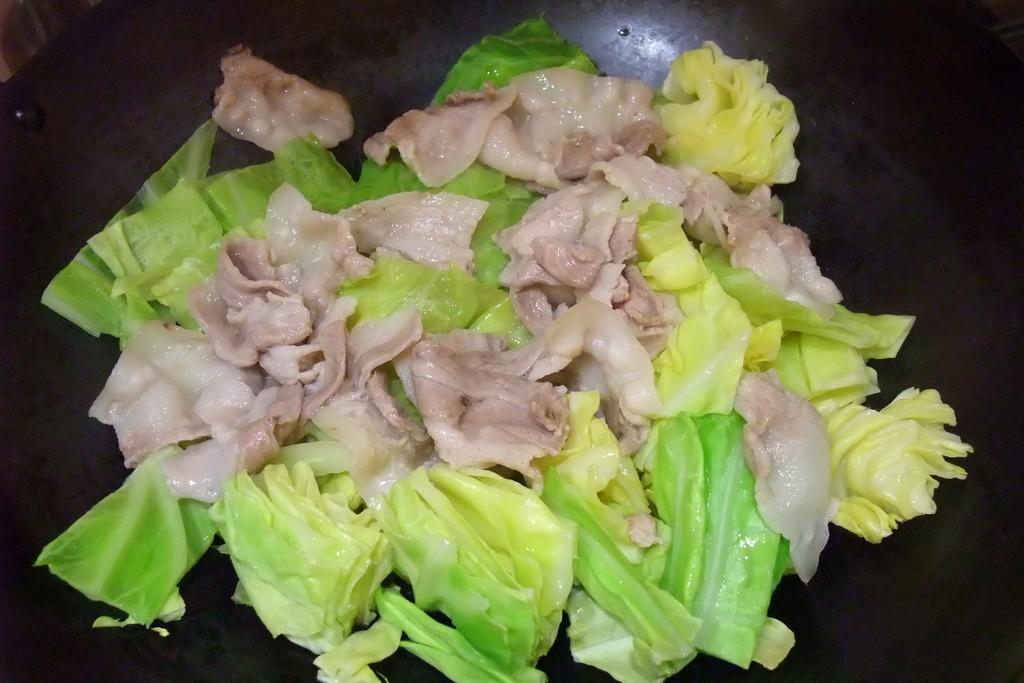What is the main subject of the image? The main subject of the image is food. What can be observed about the surface on which the food is placed? The food is on a black color surface. How does the feeling of loss affect the taste of the food in the image? The image does not convey any emotions or feelings, such as loss, and therefore it cannot be determined how they might affect the taste of the food. 